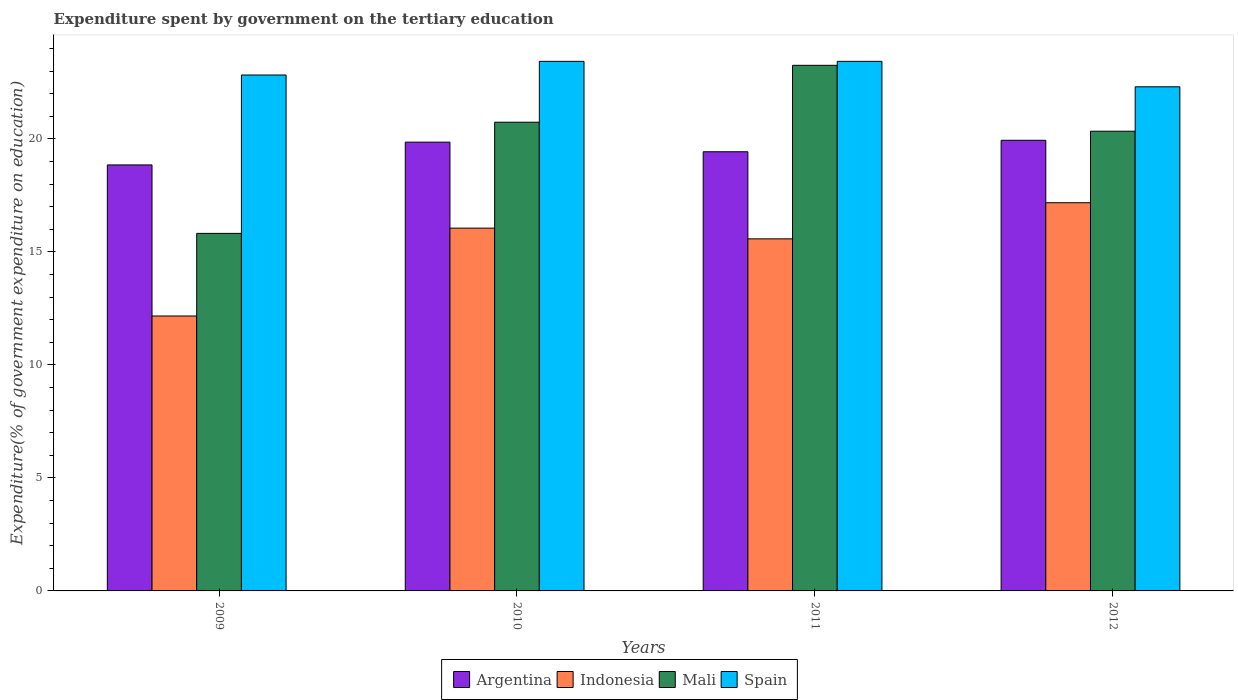How many bars are there on the 3rd tick from the right?
Give a very brief answer. 4. What is the label of the 3rd group of bars from the left?
Your answer should be very brief. 2011. In how many cases, is the number of bars for a given year not equal to the number of legend labels?
Offer a terse response. 0. What is the expenditure spent by government on the tertiary education in Indonesia in 2009?
Give a very brief answer. 12.17. Across all years, what is the maximum expenditure spent by government on the tertiary education in Indonesia?
Make the answer very short. 17.18. Across all years, what is the minimum expenditure spent by government on the tertiary education in Argentina?
Your answer should be very brief. 18.85. In which year was the expenditure spent by government on the tertiary education in Spain minimum?
Provide a short and direct response. 2012. What is the total expenditure spent by government on the tertiary education in Indonesia in the graph?
Provide a succinct answer. 60.98. What is the difference between the expenditure spent by government on the tertiary education in Argentina in 2010 and that in 2012?
Offer a very short reply. -0.08. What is the difference between the expenditure spent by government on the tertiary education in Mali in 2010 and the expenditure spent by government on the tertiary education in Spain in 2009?
Provide a short and direct response. -2.09. What is the average expenditure spent by government on the tertiary education in Argentina per year?
Ensure brevity in your answer.  19.52. In the year 2011, what is the difference between the expenditure spent by government on the tertiary education in Argentina and expenditure spent by government on the tertiary education in Mali?
Keep it short and to the point. -3.82. Is the difference between the expenditure spent by government on the tertiary education in Argentina in 2009 and 2012 greater than the difference between the expenditure spent by government on the tertiary education in Mali in 2009 and 2012?
Your response must be concise. Yes. What is the difference between the highest and the second highest expenditure spent by government on the tertiary education in Spain?
Make the answer very short. 0. What is the difference between the highest and the lowest expenditure spent by government on the tertiary education in Mali?
Your response must be concise. 7.44. Is the sum of the expenditure spent by government on the tertiary education in Spain in 2010 and 2011 greater than the maximum expenditure spent by government on the tertiary education in Indonesia across all years?
Your response must be concise. Yes. Is it the case that in every year, the sum of the expenditure spent by government on the tertiary education in Argentina and expenditure spent by government on the tertiary education in Spain is greater than the expenditure spent by government on the tertiary education in Indonesia?
Keep it short and to the point. Yes. How many bars are there?
Your answer should be very brief. 16. How many years are there in the graph?
Ensure brevity in your answer.  4. What is the difference between two consecutive major ticks on the Y-axis?
Provide a succinct answer. 5. Where does the legend appear in the graph?
Make the answer very short. Bottom center. How many legend labels are there?
Your answer should be very brief. 4. What is the title of the graph?
Provide a succinct answer. Expenditure spent by government on the tertiary education. What is the label or title of the Y-axis?
Make the answer very short. Expenditure(% of government expenditure on education). What is the Expenditure(% of government expenditure on education) in Argentina in 2009?
Make the answer very short. 18.85. What is the Expenditure(% of government expenditure on education) of Indonesia in 2009?
Offer a terse response. 12.17. What is the Expenditure(% of government expenditure on education) of Mali in 2009?
Your response must be concise. 15.82. What is the Expenditure(% of government expenditure on education) in Spain in 2009?
Provide a short and direct response. 22.83. What is the Expenditure(% of government expenditure on education) in Argentina in 2010?
Provide a short and direct response. 19.86. What is the Expenditure(% of government expenditure on education) of Indonesia in 2010?
Ensure brevity in your answer.  16.05. What is the Expenditure(% of government expenditure on education) of Mali in 2010?
Keep it short and to the point. 20.74. What is the Expenditure(% of government expenditure on education) in Spain in 2010?
Your answer should be very brief. 23.43. What is the Expenditure(% of government expenditure on education) of Argentina in 2011?
Your response must be concise. 19.43. What is the Expenditure(% of government expenditure on education) in Indonesia in 2011?
Give a very brief answer. 15.58. What is the Expenditure(% of government expenditure on education) in Mali in 2011?
Your response must be concise. 23.26. What is the Expenditure(% of government expenditure on education) of Spain in 2011?
Offer a very short reply. 23.43. What is the Expenditure(% of government expenditure on education) of Argentina in 2012?
Make the answer very short. 19.94. What is the Expenditure(% of government expenditure on education) in Indonesia in 2012?
Provide a succinct answer. 17.18. What is the Expenditure(% of government expenditure on education) of Mali in 2012?
Provide a succinct answer. 20.34. What is the Expenditure(% of government expenditure on education) of Spain in 2012?
Your answer should be compact. 22.31. Across all years, what is the maximum Expenditure(% of government expenditure on education) in Argentina?
Provide a short and direct response. 19.94. Across all years, what is the maximum Expenditure(% of government expenditure on education) in Indonesia?
Provide a short and direct response. 17.18. Across all years, what is the maximum Expenditure(% of government expenditure on education) of Mali?
Offer a terse response. 23.26. Across all years, what is the maximum Expenditure(% of government expenditure on education) of Spain?
Offer a terse response. 23.43. Across all years, what is the minimum Expenditure(% of government expenditure on education) in Argentina?
Your answer should be very brief. 18.85. Across all years, what is the minimum Expenditure(% of government expenditure on education) of Indonesia?
Your answer should be compact. 12.17. Across all years, what is the minimum Expenditure(% of government expenditure on education) of Mali?
Offer a terse response. 15.82. Across all years, what is the minimum Expenditure(% of government expenditure on education) of Spain?
Ensure brevity in your answer.  22.31. What is the total Expenditure(% of government expenditure on education) in Argentina in the graph?
Ensure brevity in your answer.  78.08. What is the total Expenditure(% of government expenditure on education) in Indonesia in the graph?
Ensure brevity in your answer.  60.98. What is the total Expenditure(% of government expenditure on education) in Mali in the graph?
Your answer should be very brief. 80.16. What is the total Expenditure(% of government expenditure on education) of Spain in the graph?
Provide a succinct answer. 92. What is the difference between the Expenditure(% of government expenditure on education) of Argentina in 2009 and that in 2010?
Keep it short and to the point. -1.01. What is the difference between the Expenditure(% of government expenditure on education) in Indonesia in 2009 and that in 2010?
Keep it short and to the point. -3.89. What is the difference between the Expenditure(% of government expenditure on education) of Mali in 2009 and that in 2010?
Your response must be concise. -4.92. What is the difference between the Expenditure(% of government expenditure on education) in Spain in 2009 and that in 2010?
Your response must be concise. -0.6. What is the difference between the Expenditure(% of government expenditure on education) in Argentina in 2009 and that in 2011?
Your answer should be very brief. -0.58. What is the difference between the Expenditure(% of government expenditure on education) of Indonesia in 2009 and that in 2011?
Provide a succinct answer. -3.41. What is the difference between the Expenditure(% of government expenditure on education) of Mali in 2009 and that in 2011?
Provide a succinct answer. -7.44. What is the difference between the Expenditure(% of government expenditure on education) of Spain in 2009 and that in 2011?
Make the answer very short. -0.6. What is the difference between the Expenditure(% of government expenditure on education) of Argentina in 2009 and that in 2012?
Your answer should be very brief. -1.09. What is the difference between the Expenditure(% of government expenditure on education) of Indonesia in 2009 and that in 2012?
Ensure brevity in your answer.  -5.01. What is the difference between the Expenditure(% of government expenditure on education) in Mali in 2009 and that in 2012?
Your response must be concise. -4.52. What is the difference between the Expenditure(% of government expenditure on education) in Spain in 2009 and that in 2012?
Keep it short and to the point. 0.52. What is the difference between the Expenditure(% of government expenditure on education) in Argentina in 2010 and that in 2011?
Your response must be concise. 0.43. What is the difference between the Expenditure(% of government expenditure on education) of Indonesia in 2010 and that in 2011?
Provide a short and direct response. 0.47. What is the difference between the Expenditure(% of government expenditure on education) of Mali in 2010 and that in 2011?
Provide a short and direct response. -2.52. What is the difference between the Expenditure(% of government expenditure on education) in Spain in 2010 and that in 2011?
Provide a short and direct response. 0. What is the difference between the Expenditure(% of government expenditure on education) of Argentina in 2010 and that in 2012?
Ensure brevity in your answer.  -0.08. What is the difference between the Expenditure(% of government expenditure on education) of Indonesia in 2010 and that in 2012?
Provide a short and direct response. -1.12. What is the difference between the Expenditure(% of government expenditure on education) in Mali in 2010 and that in 2012?
Your response must be concise. 0.4. What is the difference between the Expenditure(% of government expenditure on education) of Spain in 2010 and that in 2012?
Offer a terse response. 1.13. What is the difference between the Expenditure(% of government expenditure on education) of Argentina in 2011 and that in 2012?
Offer a terse response. -0.51. What is the difference between the Expenditure(% of government expenditure on education) in Indonesia in 2011 and that in 2012?
Your response must be concise. -1.6. What is the difference between the Expenditure(% of government expenditure on education) in Mali in 2011 and that in 2012?
Keep it short and to the point. 2.92. What is the difference between the Expenditure(% of government expenditure on education) of Spain in 2011 and that in 2012?
Your answer should be very brief. 1.13. What is the difference between the Expenditure(% of government expenditure on education) in Argentina in 2009 and the Expenditure(% of government expenditure on education) in Indonesia in 2010?
Provide a succinct answer. 2.8. What is the difference between the Expenditure(% of government expenditure on education) in Argentina in 2009 and the Expenditure(% of government expenditure on education) in Mali in 2010?
Your answer should be very brief. -1.89. What is the difference between the Expenditure(% of government expenditure on education) in Argentina in 2009 and the Expenditure(% of government expenditure on education) in Spain in 2010?
Provide a short and direct response. -4.58. What is the difference between the Expenditure(% of government expenditure on education) in Indonesia in 2009 and the Expenditure(% of government expenditure on education) in Mali in 2010?
Your answer should be very brief. -8.57. What is the difference between the Expenditure(% of government expenditure on education) of Indonesia in 2009 and the Expenditure(% of government expenditure on education) of Spain in 2010?
Provide a short and direct response. -11.27. What is the difference between the Expenditure(% of government expenditure on education) of Mali in 2009 and the Expenditure(% of government expenditure on education) of Spain in 2010?
Offer a terse response. -7.61. What is the difference between the Expenditure(% of government expenditure on education) in Argentina in 2009 and the Expenditure(% of government expenditure on education) in Indonesia in 2011?
Provide a succinct answer. 3.27. What is the difference between the Expenditure(% of government expenditure on education) in Argentina in 2009 and the Expenditure(% of government expenditure on education) in Mali in 2011?
Make the answer very short. -4.41. What is the difference between the Expenditure(% of government expenditure on education) in Argentina in 2009 and the Expenditure(% of government expenditure on education) in Spain in 2011?
Make the answer very short. -4.58. What is the difference between the Expenditure(% of government expenditure on education) in Indonesia in 2009 and the Expenditure(% of government expenditure on education) in Mali in 2011?
Offer a very short reply. -11.09. What is the difference between the Expenditure(% of government expenditure on education) in Indonesia in 2009 and the Expenditure(% of government expenditure on education) in Spain in 2011?
Your answer should be compact. -11.27. What is the difference between the Expenditure(% of government expenditure on education) in Mali in 2009 and the Expenditure(% of government expenditure on education) in Spain in 2011?
Keep it short and to the point. -7.61. What is the difference between the Expenditure(% of government expenditure on education) in Argentina in 2009 and the Expenditure(% of government expenditure on education) in Indonesia in 2012?
Your answer should be compact. 1.67. What is the difference between the Expenditure(% of government expenditure on education) of Argentina in 2009 and the Expenditure(% of government expenditure on education) of Mali in 2012?
Keep it short and to the point. -1.49. What is the difference between the Expenditure(% of government expenditure on education) of Argentina in 2009 and the Expenditure(% of government expenditure on education) of Spain in 2012?
Your response must be concise. -3.46. What is the difference between the Expenditure(% of government expenditure on education) in Indonesia in 2009 and the Expenditure(% of government expenditure on education) in Mali in 2012?
Your answer should be very brief. -8.18. What is the difference between the Expenditure(% of government expenditure on education) in Indonesia in 2009 and the Expenditure(% of government expenditure on education) in Spain in 2012?
Your answer should be very brief. -10.14. What is the difference between the Expenditure(% of government expenditure on education) in Mali in 2009 and the Expenditure(% of government expenditure on education) in Spain in 2012?
Make the answer very short. -6.49. What is the difference between the Expenditure(% of government expenditure on education) of Argentina in 2010 and the Expenditure(% of government expenditure on education) of Indonesia in 2011?
Your answer should be compact. 4.28. What is the difference between the Expenditure(% of government expenditure on education) of Argentina in 2010 and the Expenditure(% of government expenditure on education) of Mali in 2011?
Provide a succinct answer. -3.4. What is the difference between the Expenditure(% of government expenditure on education) in Argentina in 2010 and the Expenditure(% of government expenditure on education) in Spain in 2011?
Your answer should be compact. -3.58. What is the difference between the Expenditure(% of government expenditure on education) in Indonesia in 2010 and the Expenditure(% of government expenditure on education) in Mali in 2011?
Offer a terse response. -7.2. What is the difference between the Expenditure(% of government expenditure on education) in Indonesia in 2010 and the Expenditure(% of government expenditure on education) in Spain in 2011?
Provide a succinct answer. -7.38. What is the difference between the Expenditure(% of government expenditure on education) of Mali in 2010 and the Expenditure(% of government expenditure on education) of Spain in 2011?
Your response must be concise. -2.69. What is the difference between the Expenditure(% of government expenditure on education) in Argentina in 2010 and the Expenditure(% of government expenditure on education) in Indonesia in 2012?
Make the answer very short. 2.68. What is the difference between the Expenditure(% of government expenditure on education) in Argentina in 2010 and the Expenditure(% of government expenditure on education) in Mali in 2012?
Ensure brevity in your answer.  -0.48. What is the difference between the Expenditure(% of government expenditure on education) of Argentina in 2010 and the Expenditure(% of government expenditure on education) of Spain in 2012?
Offer a very short reply. -2.45. What is the difference between the Expenditure(% of government expenditure on education) of Indonesia in 2010 and the Expenditure(% of government expenditure on education) of Mali in 2012?
Offer a terse response. -4.29. What is the difference between the Expenditure(% of government expenditure on education) of Indonesia in 2010 and the Expenditure(% of government expenditure on education) of Spain in 2012?
Offer a very short reply. -6.25. What is the difference between the Expenditure(% of government expenditure on education) of Mali in 2010 and the Expenditure(% of government expenditure on education) of Spain in 2012?
Offer a very short reply. -1.57. What is the difference between the Expenditure(% of government expenditure on education) in Argentina in 2011 and the Expenditure(% of government expenditure on education) in Indonesia in 2012?
Your answer should be very brief. 2.25. What is the difference between the Expenditure(% of government expenditure on education) of Argentina in 2011 and the Expenditure(% of government expenditure on education) of Mali in 2012?
Give a very brief answer. -0.91. What is the difference between the Expenditure(% of government expenditure on education) of Argentina in 2011 and the Expenditure(% of government expenditure on education) of Spain in 2012?
Ensure brevity in your answer.  -2.87. What is the difference between the Expenditure(% of government expenditure on education) of Indonesia in 2011 and the Expenditure(% of government expenditure on education) of Mali in 2012?
Offer a terse response. -4.76. What is the difference between the Expenditure(% of government expenditure on education) in Indonesia in 2011 and the Expenditure(% of government expenditure on education) in Spain in 2012?
Your answer should be compact. -6.73. What is the difference between the Expenditure(% of government expenditure on education) of Mali in 2011 and the Expenditure(% of government expenditure on education) of Spain in 2012?
Keep it short and to the point. 0.95. What is the average Expenditure(% of government expenditure on education) of Argentina per year?
Give a very brief answer. 19.52. What is the average Expenditure(% of government expenditure on education) of Indonesia per year?
Make the answer very short. 15.24. What is the average Expenditure(% of government expenditure on education) in Mali per year?
Your response must be concise. 20.04. What is the average Expenditure(% of government expenditure on education) in Spain per year?
Your answer should be very brief. 23. In the year 2009, what is the difference between the Expenditure(% of government expenditure on education) in Argentina and Expenditure(% of government expenditure on education) in Indonesia?
Ensure brevity in your answer.  6.68. In the year 2009, what is the difference between the Expenditure(% of government expenditure on education) of Argentina and Expenditure(% of government expenditure on education) of Mali?
Offer a terse response. 3.03. In the year 2009, what is the difference between the Expenditure(% of government expenditure on education) in Argentina and Expenditure(% of government expenditure on education) in Spain?
Make the answer very short. -3.98. In the year 2009, what is the difference between the Expenditure(% of government expenditure on education) of Indonesia and Expenditure(% of government expenditure on education) of Mali?
Give a very brief answer. -3.66. In the year 2009, what is the difference between the Expenditure(% of government expenditure on education) of Indonesia and Expenditure(% of government expenditure on education) of Spain?
Ensure brevity in your answer.  -10.66. In the year 2009, what is the difference between the Expenditure(% of government expenditure on education) in Mali and Expenditure(% of government expenditure on education) in Spain?
Provide a short and direct response. -7.01. In the year 2010, what is the difference between the Expenditure(% of government expenditure on education) in Argentina and Expenditure(% of government expenditure on education) in Indonesia?
Provide a short and direct response. 3.8. In the year 2010, what is the difference between the Expenditure(% of government expenditure on education) of Argentina and Expenditure(% of government expenditure on education) of Mali?
Offer a terse response. -0.88. In the year 2010, what is the difference between the Expenditure(% of government expenditure on education) in Argentina and Expenditure(% of government expenditure on education) in Spain?
Offer a very short reply. -3.58. In the year 2010, what is the difference between the Expenditure(% of government expenditure on education) of Indonesia and Expenditure(% of government expenditure on education) of Mali?
Keep it short and to the point. -4.69. In the year 2010, what is the difference between the Expenditure(% of government expenditure on education) of Indonesia and Expenditure(% of government expenditure on education) of Spain?
Your answer should be compact. -7.38. In the year 2010, what is the difference between the Expenditure(% of government expenditure on education) of Mali and Expenditure(% of government expenditure on education) of Spain?
Make the answer very short. -2.69. In the year 2011, what is the difference between the Expenditure(% of government expenditure on education) in Argentina and Expenditure(% of government expenditure on education) in Indonesia?
Your response must be concise. 3.85. In the year 2011, what is the difference between the Expenditure(% of government expenditure on education) in Argentina and Expenditure(% of government expenditure on education) in Mali?
Provide a succinct answer. -3.82. In the year 2011, what is the difference between the Expenditure(% of government expenditure on education) in Argentina and Expenditure(% of government expenditure on education) in Spain?
Keep it short and to the point. -4. In the year 2011, what is the difference between the Expenditure(% of government expenditure on education) in Indonesia and Expenditure(% of government expenditure on education) in Mali?
Your answer should be compact. -7.68. In the year 2011, what is the difference between the Expenditure(% of government expenditure on education) of Indonesia and Expenditure(% of government expenditure on education) of Spain?
Offer a very short reply. -7.85. In the year 2011, what is the difference between the Expenditure(% of government expenditure on education) in Mali and Expenditure(% of government expenditure on education) in Spain?
Your answer should be very brief. -0.18. In the year 2012, what is the difference between the Expenditure(% of government expenditure on education) in Argentina and Expenditure(% of government expenditure on education) in Indonesia?
Your answer should be compact. 2.76. In the year 2012, what is the difference between the Expenditure(% of government expenditure on education) of Argentina and Expenditure(% of government expenditure on education) of Mali?
Make the answer very short. -0.4. In the year 2012, what is the difference between the Expenditure(% of government expenditure on education) in Argentina and Expenditure(% of government expenditure on education) in Spain?
Make the answer very short. -2.37. In the year 2012, what is the difference between the Expenditure(% of government expenditure on education) of Indonesia and Expenditure(% of government expenditure on education) of Mali?
Keep it short and to the point. -3.16. In the year 2012, what is the difference between the Expenditure(% of government expenditure on education) of Indonesia and Expenditure(% of government expenditure on education) of Spain?
Your response must be concise. -5.13. In the year 2012, what is the difference between the Expenditure(% of government expenditure on education) of Mali and Expenditure(% of government expenditure on education) of Spain?
Your answer should be very brief. -1.96. What is the ratio of the Expenditure(% of government expenditure on education) of Argentina in 2009 to that in 2010?
Ensure brevity in your answer.  0.95. What is the ratio of the Expenditure(% of government expenditure on education) of Indonesia in 2009 to that in 2010?
Your answer should be compact. 0.76. What is the ratio of the Expenditure(% of government expenditure on education) of Mali in 2009 to that in 2010?
Offer a terse response. 0.76. What is the ratio of the Expenditure(% of government expenditure on education) of Spain in 2009 to that in 2010?
Provide a succinct answer. 0.97. What is the ratio of the Expenditure(% of government expenditure on education) of Indonesia in 2009 to that in 2011?
Provide a short and direct response. 0.78. What is the ratio of the Expenditure(% of government expenditure on education) in Mali in 2009 to that in 2011?
Offer a very short reply. 0.68. What is the ratio of the Expenditure(% of government expenditure on education) in Spain in 2009 to that in 2011?
Your answer should be compact. 0.97. What is the ratio of the Expenditure(% of government expenditure on education) in Argentina in 2009 to that in 2012?
Provide a short and direct response. 0.95. What is the ratio of the Expenditure(% of government expenditure on education) in Indonesia in 2009 to that in 2012?
Your answer should be very brief. 0.71. What is the ratio of the Expenditure(% of government expenditure on education) in Spain in 2009 to that in 2012?
Provide a short and direct response. 1.02. What is the ratio of the Expenditure(% of government expenditure on education) of Argentina in 2010 to that in 2011?
Give a very brief answer. 1.02. What is the ratio of the Expenditure(% of government expenditure on education) in Indonesia in 2010 to that in 2011?
Your answer should be compact. 1.03. What is the ratio of the Expenditure(% of government expenditure on education) in Mali in 2010 to that in 2011?
Your answer should be very brief. 0.89. What is the ratio of the Expenditure(% of government expenditure on education) of Spain in 2010 to that in 2011?
Make the answer very short. 1. What is the ratio of the Expenditure(% of government expenditure on education) of Argentina in 2010 to that in 2012?
Offer a terse response. 1. What is the ratio of the Expenditure(% of government expenditure on education) in Indonesia in 2010 to that in 2012?
Give a very brief answer. 0.93. What is the ratio of the Expenditure(% of government expenditure on education) in Mali in 2010 to that in 2012?
Provide a succinct answer. 1.02. What is the ratio of the Expenditure(% of government expenditure on education) in Spain in 2010 to that in 2012?
Keep it short and to the point. 1.05. What is the ratio of the Expenditure(% of government expenditure on education) in Argentina in 2011 to that in 2012?
Give a very brief answer. 0.97. What is the ratio of the Expenditure(% of government expenditure on education) in Indonesia in 2011 to that in 2012?
Ensure brevity in your answer.  0.91. What is the ratio of the Expenditure(% of government expenditure on education) of Mali in 2011 to that in 2012?
Your answer should be compact. 1.14. What is the ratio of the Expenditure(% of government expenditure on education) of Spain in 2011 to that in 2012?
Give a very brief answer. 1.05. What is the difference between the highest and the second highest Expenditure(% of government expenditure on education) in Argentina?
Your response must be concise. 0.08. What is the difference between the highest and the second highest Expenditure(% of government expenditure on education) of Indonesia?
Give a very brief answer. 1.12. What is the difference between the highest and the second highest Expenditure(% of government expenditure on education) of Mali?
Keep it short and to the point. 2.52. What is the difference between the highest and the lowest Expenditure(% of government expenditure on education) in Argentina?
Your answer should be very brief. 1.09. What is the difference between the highest and the lowest Expenditure(% of government expenditure on education) of Indonesia?
Provide a succinct answer. 5.01. What is the difference between the highest and the lowest Expenditure(% of government expenditure on education) of Mali?
Offer a terse response. 7.44. What is the difference between the highest and the lowest Expenditure(% of government expenditure on education) of Spain?
Offer a very short reply. 1.13. 